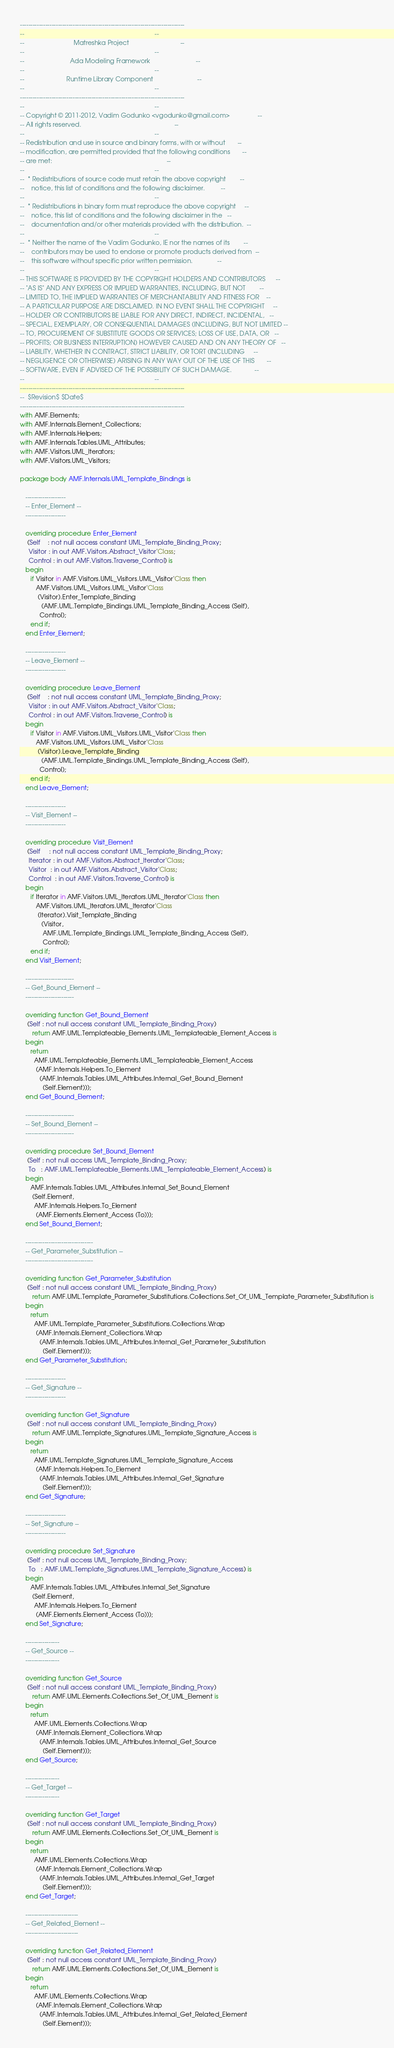<code> <loc_0><loc_0><loc_500><loc_500><_Ada_>------------------------------------------------------------------------------
--                                                                          --
--                            Matreshka Project                             --
--                                                                          --
--                          Ada Modeling Framework                          --
--                                                                          --
--                        Runtime Library Component                         --
--                                                                          --
------------------------------------------------------------------------------
--                                                                          --
-- Copyright © 2011-2012, Vadim Godunko <vgodunko@gmail.com>                --
-- All rights reserved.                                                     --
--                                                                          --
-- Redistribution and use in source and binary forms, with or without       --
-- modification, are permitted provided that the following conditions       --
-- are met:                                                                 --
--                                                                          --
--  * Redistributions of source code must retain the above copyright        --
--    notice, this list of conditions and the following disclaimer.         --
--                                                                          --
--  * Redistributions in binary form must reproduce the above copyright     --
--    notice, this list of conditions and the following disclaimer in the   --
--    documentation and/or other materials provided with the distribution.  --
--                                                                          --
--  * Neither the name of the Vadim Godunko, IE nor the names of its        --
--    contributors may be used to endorse or promote products derived from  --
--    this software without specific prior written permission.              --
--                                                                          --
-- THIS SOFTWARE IS PROVIDED BY THE COPYRIGHT HOLDERS AND CONTRIBUTORS      --
-- "AS IS" AND ANY EXPRESS OR IMPLIED WARRANTIES, INCLUDING, BUT NOT        --
-- LIMITED TO, THE IMPLIED WARRANTIES OF MERCHANTABILITY AND FITNESS FOR    --
-- A PARTICULAR PURPOSE ARE DISCLAIMED. IN NO EVENT SHALL THE COPYRIGHT     --
-- HOLDER OR CONTRIBUTORS BE LIABLE FOR ANY DIRECT, INDIRECT, INCIDENTAL,   --
-- SPECIAL, EXEMPLARY, OR CONSEQUENTIAL DAMAGES (INCLUDING, BUT NOT LIMITED --
-- TO, PROCUREMENT OF SUBSTITUTE GOODS OR SERVICES; LOSS OF USE, DATA, OR   --
-- PROFITS; OR BUSINESS INTERRUPTION) HOWEVER CAUSED AND ON ANY THEORY OF   --
-- LIABILITY, WHETHER IN CONTRACT, STRICT LIABILITY, OR TORT (INCLUDING     --
-- NEGLIGENCE OR OTHERWISE) ARISING IN ANY WAY OUT OF THE USE OF THIS       --
-- SOFTWARE, EVEN IF ADVISED OF THE POSSIBILITY OF SUCH DAMAGE.             --
--                                                                          --
------------------------------------------------------------------------------
--  $Revision$ $Date$
------------------------------------------------------------------------------
with AMF.Elements;
with AMF.Internals.Element_Collections;
with AMF.Internals.Helpers;
with AMF.Internals.Tables.UML_Attributes;
with AMF.Visitors.UML_Iterators;
with AMF.Visitors.UML_Visitors;

package body AMF.Internals.UML_Template_Bindings is

   -------------------
   -- Enter_Element --
   -------------------

   overriding procedure Enter_Element
    (Self    : not null access constant UML_Template_Binding_Proxy;
     Visitor : in out AMF.Visitors.Abstract_Visitor'Class;
     Control : in out AMF.Visitors.Traverse_Control) is
   begin
      if Visitor in AMF.Visitors.UML_Visitors.UML_Visitor'Class then
         AMF.Visitors.UML_Visitors.UML_Visitor'Class
          (Visitor).Enter_Template_Binding
            (AMF.UML.Template_Bindings.UML_Template_Binding_Access (Self),
           Control);
      end if;
   end Enter_Element;

   -------------------
   -- Leave_Element --
   -------------------

   overriding procedure Leave_Element
    (Self    : not null access constant UML_Template_Binding_Proxy;
     Visitor : in out AMF.Visitors.Abstract_Visitor'Class;
     Control : in out AMF.Visitors.Traverse_Control) is
   begin
      if Visitor in AMF.Visitors.UML_Visitors.UML_Visitor'Class then
         AMF.Visitors.UML_Visitors.UML_Visitor'Class
          (Visitor).Leave_Template_Binding
            (AMF.UML.Template_Bindings.UML_Template_Binding_Access (Self),
           Control);
      end if;
   end Leave_Element;

   -------------------
   -- Visit_Element --
   -------------------

   overriding procedure Visit_Element
    (Self     : not null access constant UML_Template_Binding_Proxy;
     Iterator : in out AMF.Visitors.Abstract_Iterator'Class;
     Visitor  : in out AMF.Visitors.Abstract_Visitor'Class;
     Control  : in out AMF.Visitors.Traverse_Control) is
   begin
      if Iterator in AMF.Visitors.UML_Iterators.UML_Iterator'Class then
         AMF.Visitors.UML_Iterators.UML_Iterator'Class
          (Iterator).Visit_Template_Binding
            (Visitor,
             AMF.UML.Template_Bindings.UML_Template_Binding_Access (Self),
             Control);
      end if;
   end Visit_Element;

   -----------------------
   -- Get_Bound_Element --
   -----------------------

   overriding function Get_Bound_Element
    (Self : not null access constant UML_Template_Binding_Proxy)
       return AMF.UML.Templateable_Elements.UML_Templateable_Element_Access is
   begin
      return
        AMF.UML.Templateable_Elements.UML_Templateable_Element_Access
         (AMF.Internals.Helpers.To_Element
           (AMF.Internals.Tables.UML_Attributes.Internal_Get_Bound_Element
             (Self.Element)));
   end Get_Bound_Element;

   -----------------------
   -- Set_Bound_Element --
   -----------------------

   overriding procedure Set_Bound_Element
    (Self : not null access UML_Template_Binding_Proxy;
     To   : AMF.UML.Templateable_Elements.UML_Templateable_Element_Access) is
   begin
      AMF.Internals.Tables.UML_Attributes.Internal_Set_Bound_Element
       (Self.Element,
        AMF.Internals.Helpers.To_Element
         (AMF.Elements.Element_Access (To)));
   end Set_Bound_Element;

   --------------------------------
   -- Get_Parameter_Substitution --
   --------------------------------

   overriding function Get_Parameter_Substitution
    (Self : not null access constant UML_Template_Binding_Proxy)
       return AMF.UML.Template_Parameter_Substitutions.Collections.Set_Of_UML_Template_Parameter_Substitution is
   begin
      return
        AMF.UML.Template_Parameter_Substitutions.Collections.Wrap
         (AMF.Internals.Element_Collections.Wrap
           (AMF.Internals.Tables.UML_Attributes.Internal_Get_Parameter_Substitution
             (Self.Element)));
   end Get_Parameter_Substitution;

   -------------------
   -- Get_Signature --
   -------------------

   overriding function Get_Signature
    (Self : not null access constant UML_Template_Binding_Proxy)
       return AMF.UML.Template_Signatures.UML_Template_Signature_Access is
   begin
      return
        AMF.UML.Template_Signatures.UML_Template_Signature_Access
         (AMF.Internals.Helpers.To_Element
           (AMF.Internals.Tables.UML_Attributes.Internal_Get_Signature
             (Self.Element)));
   end Get_Signature;

   -------------------
   -- Set_Signature --
   -------------------

   overriding procedure Set_Signature
    (Self : not null access UML_Template_Binding_Proxy;
     To   : AMF.UML.Template_Signatures.UML_Template_Signature_Access) is
   begin
      AMF.Internals.Tables.UML_Attributes.Internal_Set_Signature
       (Self.Element,
        AMF.Internals.Helpers.To_Element
         (AMF.Elements.Element_Access (To)));
   end Set_Signature;

   ----------------
   -- Get_Source --
   ----------------

   overriding function Get_Source
    (Self : not null access constant UML_Template_Binding_Proxy)
       return AMF.UML.Elements.Collections.Set_Of_UML_Element is
   begin
      return
        AMF.UML.Elements.Collections.Wrap
         (AMF.Internals.Element_Collections.Wrap
           (AMF.Internals.Tables.UML_Attributes.Internal_Get_Source
             (Self.Element)));
   end Get_Source;

   ----------------
   -- Get_Target --
   ----------------

   overriding function Get_Target
    (Self : not null access constant UML_Template_Binding_Proxy)
       return AMF.UML.Elements.Collections.Set_Of_UML_Element is
   begin
      return
        AMF.UML.Elements.Collections.Wrap
         (AMF.Internals.Element_Collections.Wrap
           (AMF.Internals.Tables.UML_Attributes.Internal_Get_Target
             (Self.Element)));
   end Get_Target;

   -------------------------
   -- Get_Related_Element --
   -------------------------

   overriding function Get_Related_Element
    (Self : not null access constant UML_Template_Binding_Proxy)
       return AMF.UML.Elements.Collections.Set_Of_UML_Element is
   begin
      return
        AMF.UML.Elements.Collections.Wrap
         (AMF.Internals.Element_Collections.Wrap
           (AMF.Internals.Tables.UML_Attributes.Internal_Get_Related_Element
             (Self.Element)));</code> 